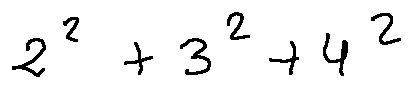<formula> <loc_0><loc_0><loc_500><loc_500>2 ^ { 2 } + 3 ^ { 2 } + 4 ^ { 2 }</formula> 